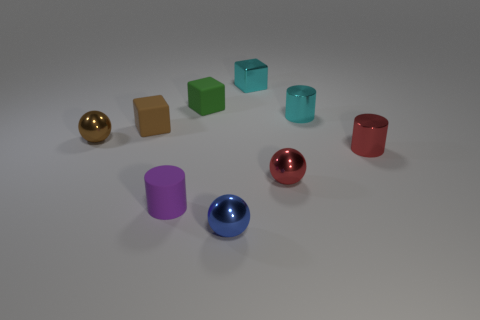Add 1 small shiny cylinders. How many objects exist? 10 Add 6 small blue objects. How many small blue objects exist? 7 Subtract all blue balls. How many balls are left? 2 Subtract all small metallic cylinders. How many cylinders are left? 1 Subtract 1 brown spheres. How many objects are left? 8 Subtract all blocks. How many objects are left? 6 Subtract 1 spheres. How many spheres are left? 2 Subtract all brown cylinders. Subtract all red cubes. How many cylinders are left? 3 Subtract all cyan spheres. How many purple cylinders are left? 1 Subtract all small blue metallic balls. Subtract all red cylinders. How many objects are left? 7 